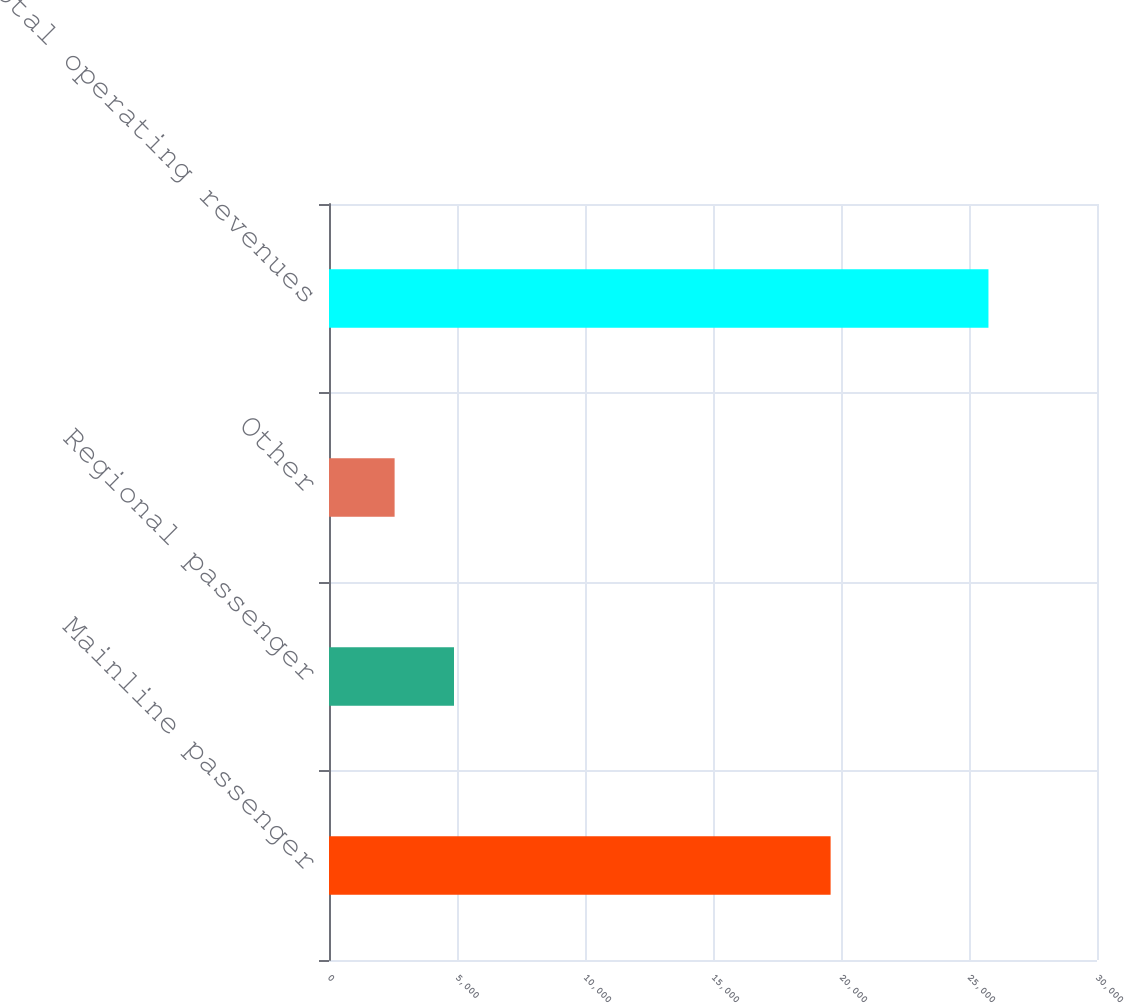<chart> <loc_0><loc_0><loc_500><loc_500><bar_chart><fcel>Mainline passenger<fcel>Regional passenger<fcel>Other<fcel>Total operating revenues<nl><fcel>19594<fcel>4882.7<fcel>2563<fcel>25760<nl></chart> 